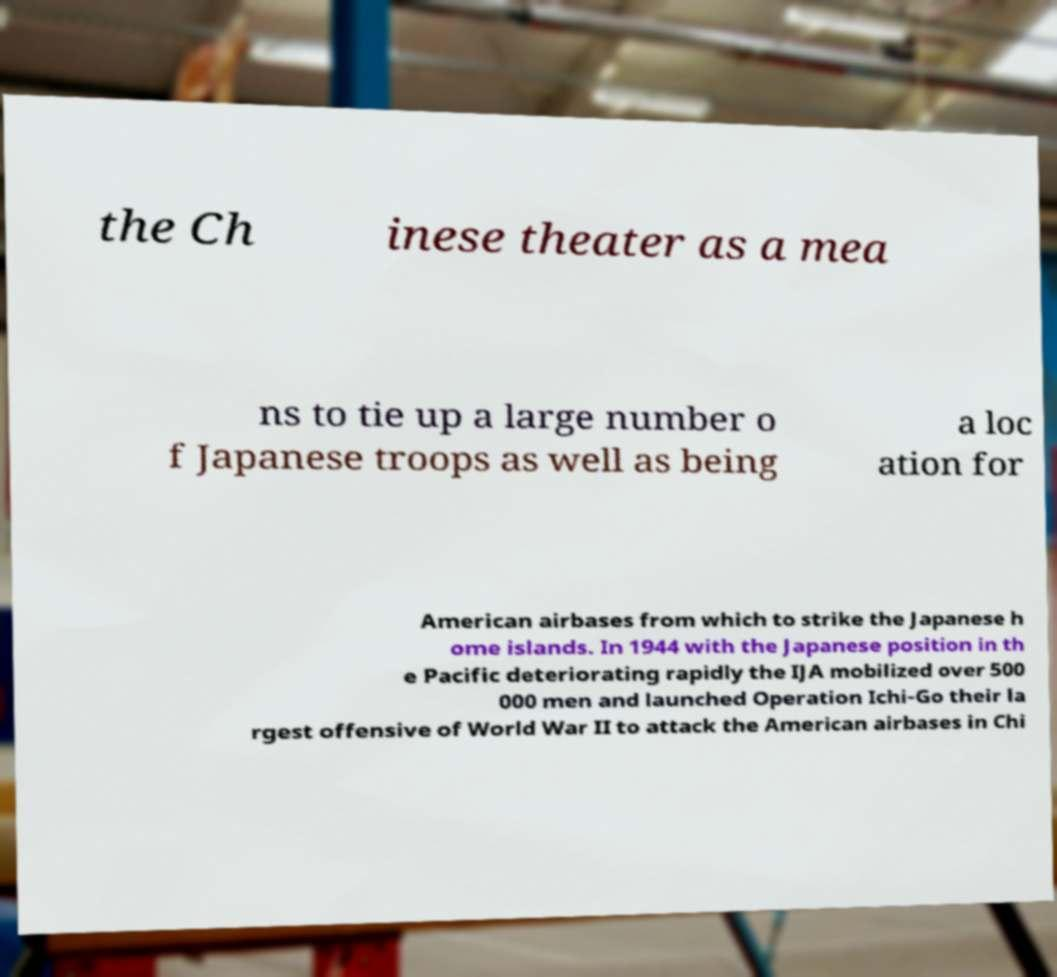I need the written content from this picture converted into text. Can you do that? the Ch inese theater as a mea ns to tie up a large number o f Japanese troops as well as being a loc ation for American airbases from which to strike the Japanese h ome islands. In 1944 with the Japanese position in th e Pacific deteriorating rapidly the IJA mobilized over 500 000 men and launched Operation Ichi-Go their la rgest offensive of World War II to attack the American airbases in Chi 